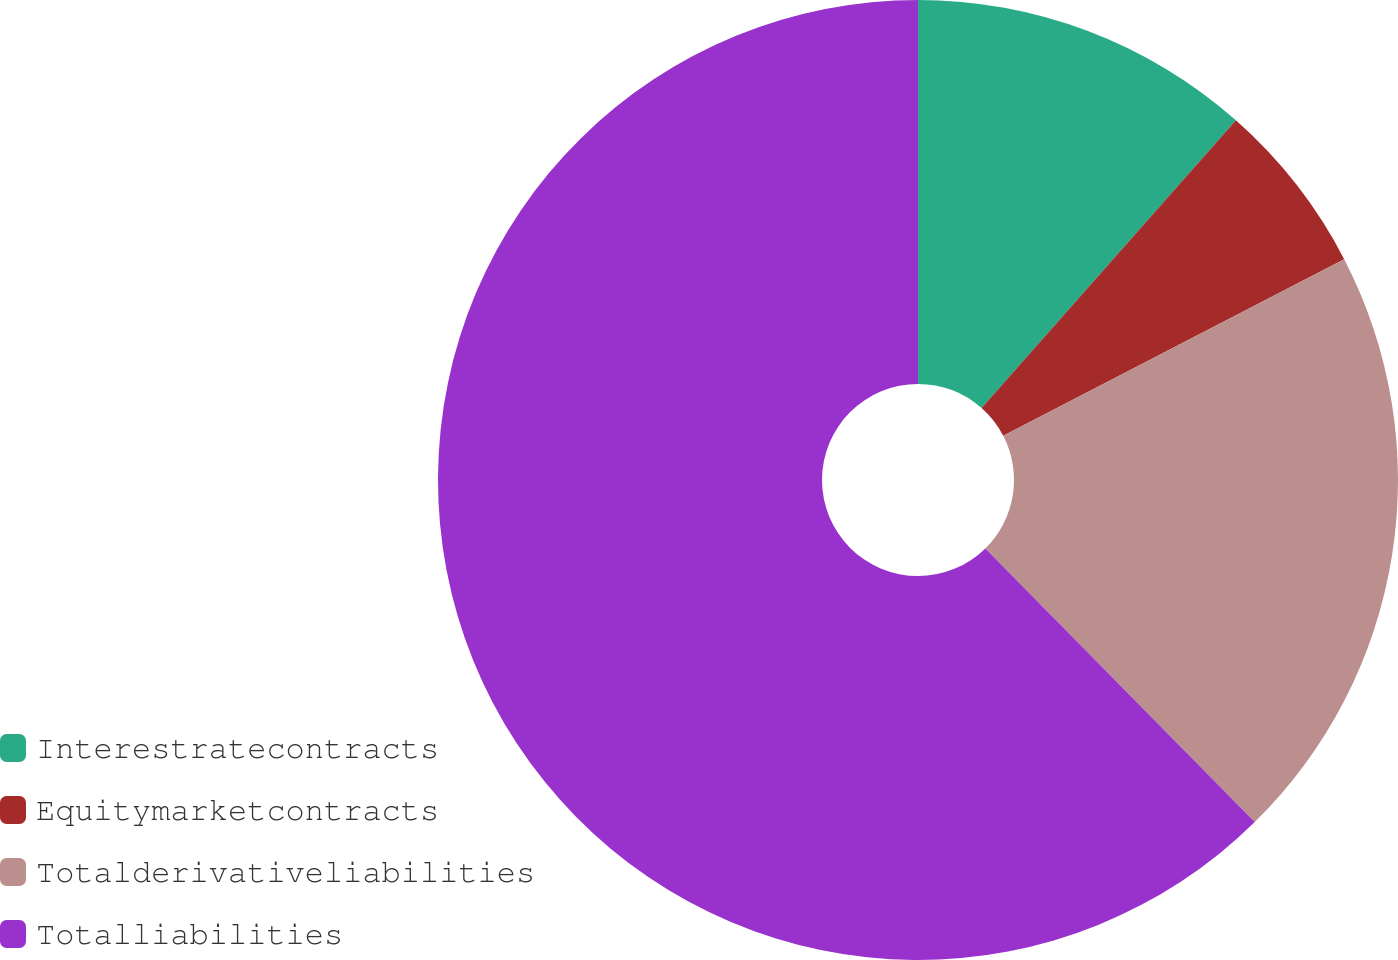Convert chart. <chart><loc_0><loc_0><loc_500><loc_500><pie_chart><fcel>Interestratecontracts<fcel>Equitymarketcontracts<fcel>Totalderivativeliabilities<fcel>Totalliabilities<nl><fcel>11.52%<fcel>5.87%<fcel>20.23%<fcel>62.37%<nl></chart> 